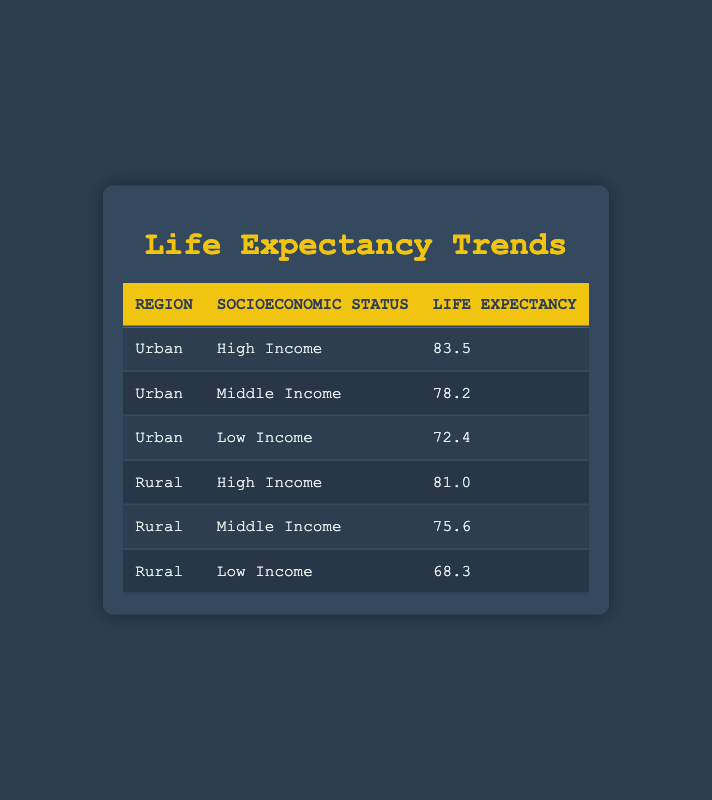What is the life expectancy for low-income individuals in urban areas? The table shows that the life expectancy for low-income individuals in urban areas is stated in the corresponding row, which lists "Urban" under region, "Low Income" under socioeconomic status, and has a life expectancy value of 72.4.
Answer: 72.4 What is the difference in life expectancy between high-income individuals in urban and rural areas? To find the difference, first, identify the life expectancy values for high-income individuals: urban is 83.5 and rural is 81.0. The difference is calculated as 83.5 - 81.0 = 2.5.
Answer: 2.5 Is the life expectancy higher for middle-income individuals in rural areas compared to low-income individuals in urban areas? From the table, the life expectancy for middle-income in rural areas is 75.6 and for low-income in urban areas is 72.4. Since 75.6 is greater than 72.4, the statement is true.
Answer: Yes What is the average life expectancy of high-income individuals across both urban and rural areas? First, gather the life expectancy values for high-income individuals: urban is 83.5 and rural is 81.0. Sum these values (83.5 + 81.0 = 164.5) and divide by 2 to get the average: 164.5 / 2 = 82.25.
Answer: 82.25 Which group has the lowest life expectancy and what is the value? By inspecting the table, the lowest life expectancy is found in the low-income group of rural areas, which has a value of 68.3.
Answer: 68.3 What is the life expectancy for middle-income individuals in urban areas? The table lists the life expectancy for middle-income individuals in urban areas directly as 78.2 in the respective row.
Answer: 78.2 Is life expectancy in rural areas collectively higher than that of urban areas for low-income individuals? The rural low-income life expectancy is 68.3, and the urban low-income life expectancy is 72.4. Since 68.3 is less than 72.4, rural areas have lower life expectancy. Therefore, the statement is false.
Answer: No How does the life expectancy of lower-income individuals in rural areas compare with that of high-income individuals in urban areas? The life expectancy for lower-income individuals in rural areas is 68.3, while for high-income individuals in urban areas it is 83.5. Comparing these values shows that 68.3 is much less than 83.5, indicating a significant difference.
Answer: Lower 